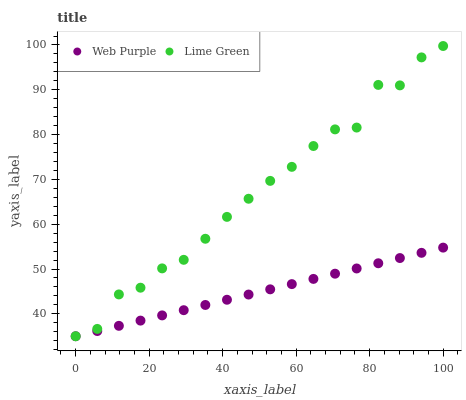Does Web Purple have the minimum area under the curve?
Answer yes or no. Yes. Does Lime Green have the maximum area under the curve?
Answer yes or no. Yes. Does Lime Green have the minimum area under the curve?
Answer yes or no. No. Is Web Purple the smoothest?
Answer yes or no. Yes. Is Lime Green the roughest?
Answer yes or no. Yes. Is Lime Green the smoothest?
Answer yes or no. No. Does Web Purple have the lowest value?
Answer yes or no. Yes. Does Lime Green have the highest value?
Answer yes or no. Yes. Does Lime Green intersect Web Purple?
Answer yes or no. Yes. Is Lime Green less than Web Purple?
Answer yes or no. No. Is Lime Green greater than Web Purple?
Answer yes or no. No. 